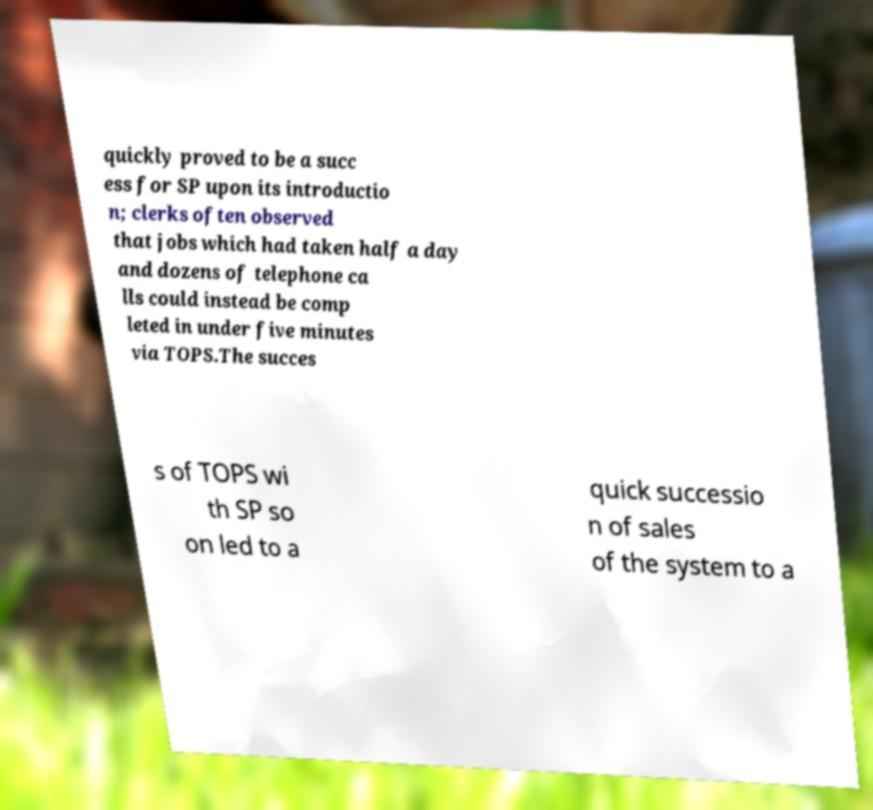Can you read and provide the text displayed in the image?This photo seems to have some interesting text. Can you extract and type it out for me? quickly proved to be a succ ess for SP upon its introductio n; clerks often observed that jobs which had taken half a day and dozens of telephone ca lls could instead be comp leted in under five minutes via TOPS.The succes s of TOPS wi th SP so on led to a quick successio n of sales of the system to a 